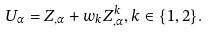<formula> <loc_0><loc_0><loc_500><loc_500>U _ { \alpha } = Z _ { , \alpha } + w _ { k } Z ^ { k } _ { , \alpha } , k \in \{ 1 , 2 \} .</formula> 